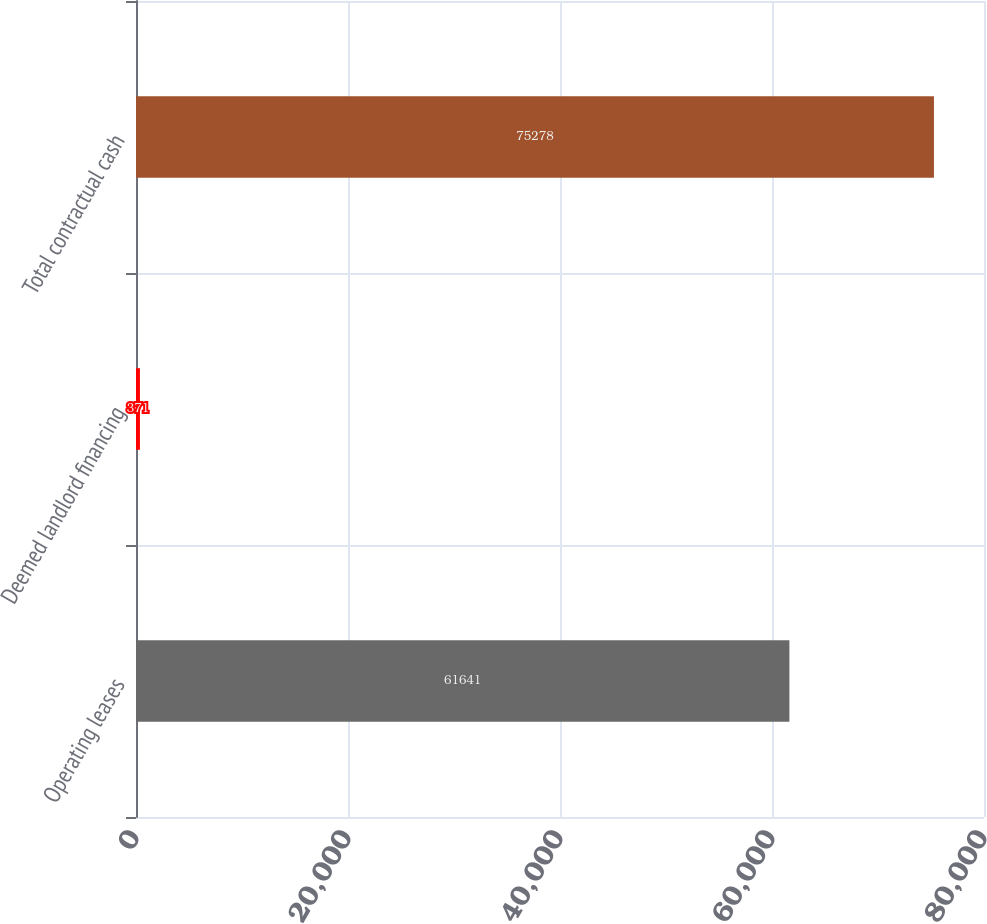Convert chart to OTSL. <chart><loc_0><loc_0><loc_500><loc_500><bar_chart><fcel>Operating leases<fcel>Deemed landlord financing<fcel>Total contractual cash<nl><fcel>61641<fcel>371<fcel>75278<nl></chart> 